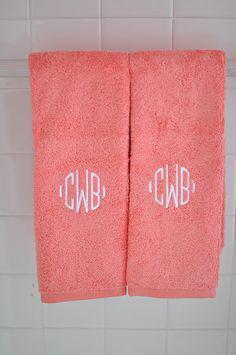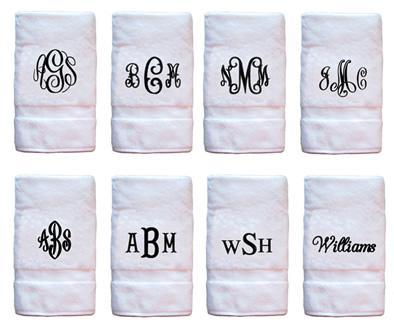The first image is the image on the left, the second image is the image on the right. Given the left and right images, does the statement "There is at least one towel that is primarily a pinkish hue in color" hold true? Answer yes or no. Yes. The first image is the image on the left, the second image is the image on the right. For the images displayed, is the sentence "The middle letter in the monogram on several of the towels is a capital R." factually correct? Answer yes or no. No. 